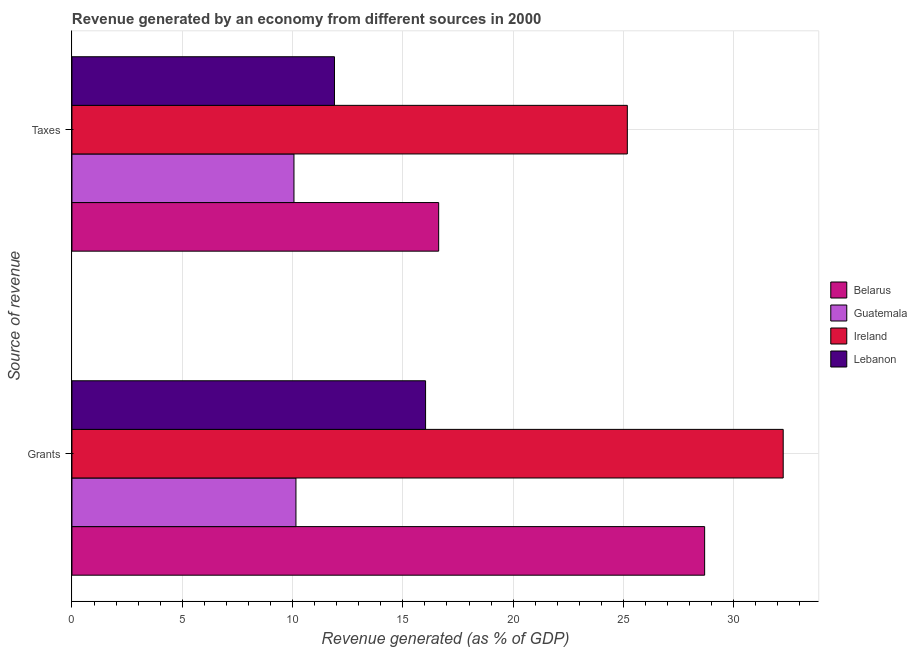Are the number of bars on each tick of the Y-axis equal?
Ensure brevity in your answer.  Yes. How many bars are there on the 2nd tick from the top?
Offer a terse response. 4. What is the label of the 2nd group of bars from the top?
Offer a terse response. Grants. What is the revenue generated by grants in Guatemala?
Your answer should be very brief. 10.15. Across all countries, what is the maximum revenue generated by taxes?
Provide a short and direct response. 25.18. Across all countries, what is the minimum revenue generated by grants?
Make the answer very short. 10.15. In which country was the revenue generated by grants maximum?
Ensure brevity in your answer.  Ireland. In which country was the revenue generated by taxes minimum?
Ensure brevity in your answer.  Guatemala. What is the total revenue generated by grants in the graph?
Provide a short and direct response. 87.11. What is the difference between the revenue generated by taxes in Guatemala and that in Ireland?
Provide a short and direct response. -15.11. What is the difference between the revenue generated by grants in Ireland and the revenue generated by taxes in Lebanon?
Offer a very short reply. 20.34. What is the average revenue generated by grants per country?
Provide a short and direct response. 21.78. What is the difference between the revenue generated by taxes and revenue generated by grants in Lebanon?
Ensure brevity in your answer.  -4.13. What is the ratio of the revenue generated by grants in Lebanon to that in Belarus?
Provide a short and direct response. 0.56. Is the revenue generated by grants in Belarus less than that in Lebanon?
Keep it short and to the point. No. What does the 2nd bar from the top in Taxes represents?
Your response must be concise. Ireland. What does the 3rd bar from the bottom in Grants represents?
Offer a terse response. Ireland. How many countries are there in the graph?
Make the answer very short. 4. Are the values on the major ticks of X-axis written in scientific E-notation?
Provide a succinct answer. No. Does the graph contain grids?
Make the answer very short. Yes. Where does the legend appear in the graph?
Provide a short and direct response. Center right. What is the title of the graph?
Make the answer very short. Revenue generated by an economy from different sources in 2000. What is the label or title of the X-axis?
Offer a very short reply. Revenue generated (as % of GDP). What is the label or title of the Y-axis?
Provide a short and direct response. Source of revenue. What is the Revenue generated (as % of GDP) of Belarus in Grants?
Provide a short and direct response. 28.68. What is the Revenue generated (as % of GDP) in Guatemala in Grants?
Make the answer very short. 10.15. What is the Revenue generated (as % of GDP) in Ireland in Grants?
Give a very brief answer. 32.24. What is the Revenue generated (as % of GDP) of Lebanon in Grants?
Your answer should be compact. 16.03. What is the Revenue generated (as % of GDP) of Belarus in Taxes?
Your response must be concise. 16.62. What is the Revenue generated (as % of GDP) in Guatemala in Taxes?
Your response must be concise. 10.06. What is the Revenue generated (as % of GDP) of Ireland in Taxes?
Make the answer very short. 25.18. What is the Revenue generated (as % of GDP) in Lebanon in Taxes?
Keep it short and to the point. 11.9. Across all Source of revenue, what is the maximum Revenue generated (as % of GDP) in Belarus?
Ensure brevity in your answer.  28.68. Across all Source of revenue, what is the maximum Revenue generated (as % of GDP) of Guatemala?
Your answer should be very brief. 10.15. Across all Source of revenue, what is the maximum Revenue generated (as % of GDP) in Ireland?
Your answer should be very brief. 32.24. Across all Source of revenue, what is the maximum Revenue generated (as % of GDP) of Lebanon?
Give a very brief answer. 16.03. Across all Source of revenue, what is the minimum Revenue generated (as % of GDP) of Belarus?
Provide a succinct answer. 16.62. Across all Source of revenue, what is the minimum Revenue generated (as % of GDP) in Guatemala?
Your answer should be very brief. 10.06. Across all Source of revenue, what is the minimum Revenue generated (as % of GDP) in Ireland?
Provide a succinct answer. 25.18. Across all Source of revenue, what is the minimum Revenue generated (as % of GDP) in Lebanon?
Provide a short and direct response. 11.9. What is the total Revenue generated (as % of GDP) of Belarus in the graph?
Provide a succinct answer. 45.31. What is the total Revenue generated (as % of GDP) of Guatemala in the graph?
Provide a succinct answer. 20.22. What is the total Revenue generated (as % of GDP) of Ireland in the graph?
Keep it short and to the point. 57.42. What is the total Revenue generated (as % of GDP) of Lebanon in the graph?
Make the answer very short. 27.93. What is the difference between the Revenue generated (as % of GDP) of Belarus in Grants and that in Taxes?
Make the answer very short. 12.06. What is the difference between the Revenue generated (as % of GDP) in Guatemala in Grants and that in Taxes?
Offer a terse response. 0.09. What is the difference between the Revenue generated (as % of GDP) of Ireland in Grants and that in Taxes?
Make the answer very short. 7.07. What is the difference between the Revenue generated (as % of GDP) of Lebanon in Grants and that in Taxes?
Your answer should be compact. 4.13. What is the difference between the Revenue generated (as % of GDP) in Belarus in Grants and the Revenue generated (as % of GDP) in Guatemala in Taxes?
Offer a terse response. 18.62. What is the difference between the Revenue generated (as % of GDP) of Belarus in Grants and the Revenue generated (as % of GDP) of Ireland in Taxes?
Provide a succinct answer. 3.5. What is the difference between the Revenue generated (as % of GDP) in Belarus in Grants and the Revenue generated (as % of GDP) in Lebanon in Taxes?
Give a very brief answer. 16.78. What is the difference between the Revenue generated (as % of GDP) of Guatemala in Grants and the Revenue generated (as % of GDP) of Ireland in Taxes?
Give a very brief answer. -15.02. What is the difference between the Revenue generated (as % of GDP) in Guatemala in Grants and the Revenue generated (as % of GDP) in Lebanon in Taxes?
Provide a succinct answer. -1.75. What is the difference between the Revenue generated (as % of GDP) in Ireland in Grants and the Revenue generated (as % of GDP) in Lebanon in Taxes?
Your answer should be compact. 20.34. What is the average Revenue generated (as % of GDP) of Belarus per Source of revenue?
Ensure brevity in your answer.  22.65. What is the average Revenue generated (as % of GDP) of Guatemala per Source of revenue?
Your answer should be very brief. 10.11. What is the average Revenue generated (as % of GDP) of Ireland per Source of revenue?
Provide a short and direct response. 28.71. What is the average Revenue generated (as % of GDP) in Lebanon per Source of revenue?
Keep it short and to the point. 13.97. What is the difference between the Revenue generated (as % of GDP) of Belarus and Revenue generated (as % of GDP) of Guatemala in Grants?
Your response must be concise. 18.53. What is the difference between the Revenue generated (as % of GDP) in Belarus and Revenue generated (as % of GDP) in Ireland in Grants?
Keep it short and to the point. -3.56. What is the difference between the Revenue generated (as % of GDP) of Belarus and Revenue generated (as % of GDP) of Lebanon in Grants?
Your answer should be compact. 12.65. What is the difference between the Revenue generated (as % of GDP) of Guatemala and Revenue generated (as % of GDP) of Ireland in Grants?
Your answer should be compact. -22.09. What is the difference between the Revenue generated (as % of GDP) of Guatemala and Revenue generated (as % of GDP) of Lebanon in Grants?
Give a very brief answer. -5.88. What is the difference between the Revenue generated (as % of GDP) in Ireland and Revenue generated (as % of GDP) in Lebanon in Grants?
Your answer should be very brief. 16.21. What is the difference between the Revenue generated (as % of GDP) in Belarus and Revenue generated (as % of GDP) in Guatemala in Taxes?
Your answer should be very brief. 6.56. What is the difference between the Revenue generated (as % of GDP) of Belarus and Revenue generated (as % of GDP) of Ireland in Taxes?
Keep it short and to the point. -8.55. What is the difference between the Revenue generated (as % of GDP) of Belarus and Revenue generated (as % of GDP) of Lebanon in Taxes?
Make the answer very short. 4.72. What is the difference between the Revenue generated (as % of GDP) in Guatemala and Revenue generated (as % of GDP) in Ireland in Taxes?
Your response must be concise. -15.11. What is the difference between the Revenue generated (as % of GDP) in Guatemala and Revenue generated (as % of GDP) in Lebanon in Taxes?
Offer a very short reply. -1.84. What is the difference between the Revenue generated (as % of GDP) in Ireland and Revenue generated (as % of GDP) in Lebanon in Taxes?
Keep it short and to the point. 13.28. What is the ratio of the Revenue generated (as % of GDP) of Belarus in Grants to that in Taxes?
Provide a short and direct response. 1.73. What is the ratio of the Revenue generated (as % of GDP) of Guatemala in Grants to that in Taxes?
Offer a very short reply. 1.01. What is the ratio of the Revenue generated (as % of GDP) of Ireland in Grants to that in Taxes?
Your answer should be compact. 1.28. What is the ratio of the Revenue generated (as % of GDP) in Lebanon in Grants to that in Taxes?
Keep it short and to the point. 1.35. What is the difference between the highest and the second highest Revenue generated (as % of GDP) in Belarus?
Provide a succinct answer. 12.06. What is the difference between the highest and the second highest Revenue generated (as % of GDP) of Guatemala?
Make the answer very short. 0.09. What is the difference between the highest and the second highest Revenue generated (as % of GDP) in Ireland?
Make the answer very short. 7.07. What is the difference between the highest and the second highest Revenue generated (as % of GDP) of Lebanon?
Provide a succinct answer. 4.13. What is the difference between the highest and the lowest Revenue generated (as % of GDP) in Belarus?
Your answer should be very brief. 12.06. What is the difference between the highest and the lowest Revenue generated (as % of GDP) of Guatemala?
Make the answer very short. 0.09. What is the difference between the highest and the lowest Revenue generated (as % of GDP) of Ireland?
Give a very brief answer. 7.07. What is the difference between the highest and the lowest Revenue generated (as % of GDP) in Lebanon?
Your answer should be compact. 4.13. 